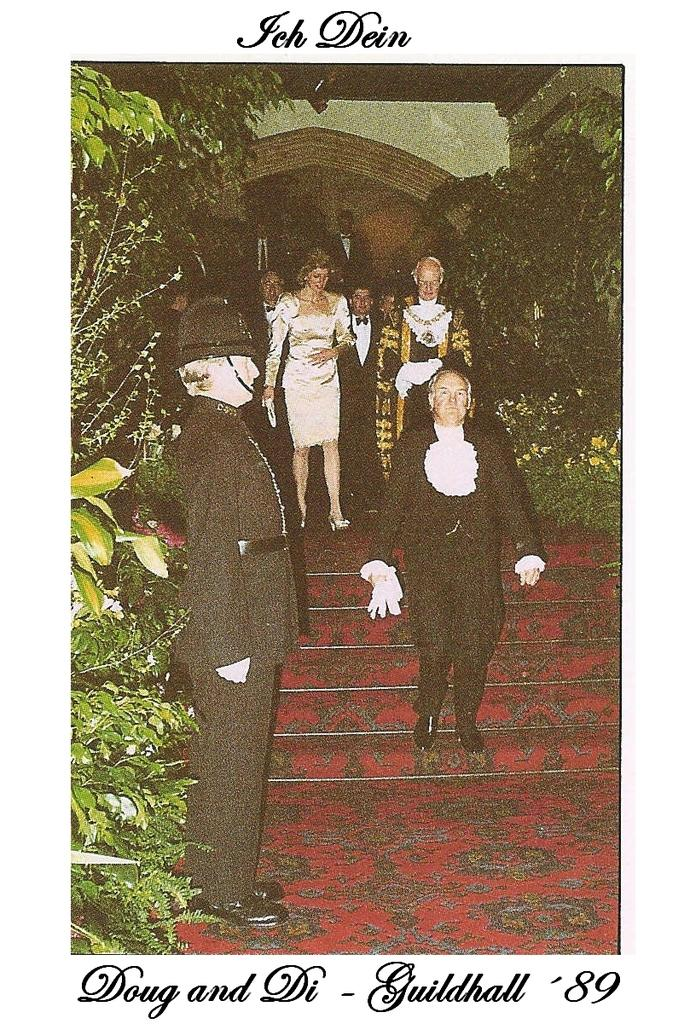What is the main subject of the image? There is a poster in the image. What types of images are present on the poster? The poster contains images of people, plants, stairs, and walls. Where is some information located on the poster? There is some information at the top and bottom of the image. How does the poster engage in a game of division in the image? The poster does not engage in any games or divisions; it is a static image containing various images and information. 